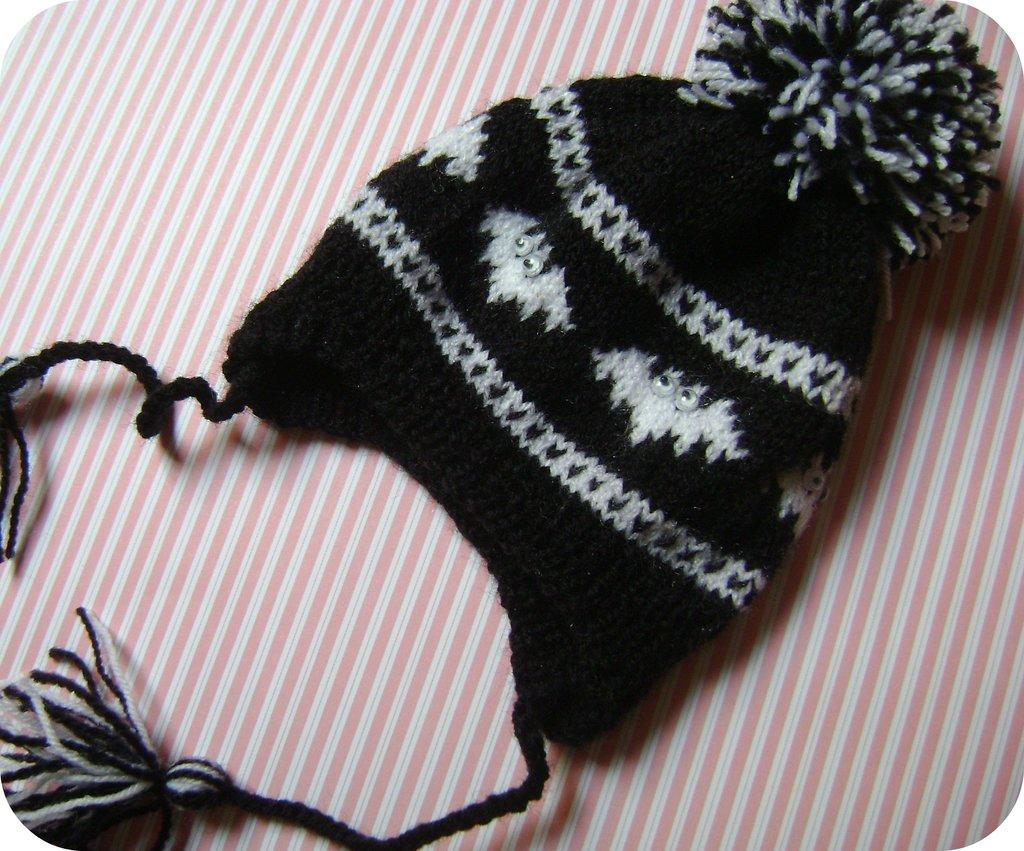What object is on the table in the image? There is a hat on the table. What is happening to the hat in the image? A finger is looping the hat. What type of cakes are being served at the magic orange party in the image? There is no mention of cakes, magic, or an orange party in the image; it only features a hat on a table with a finger looping it. 